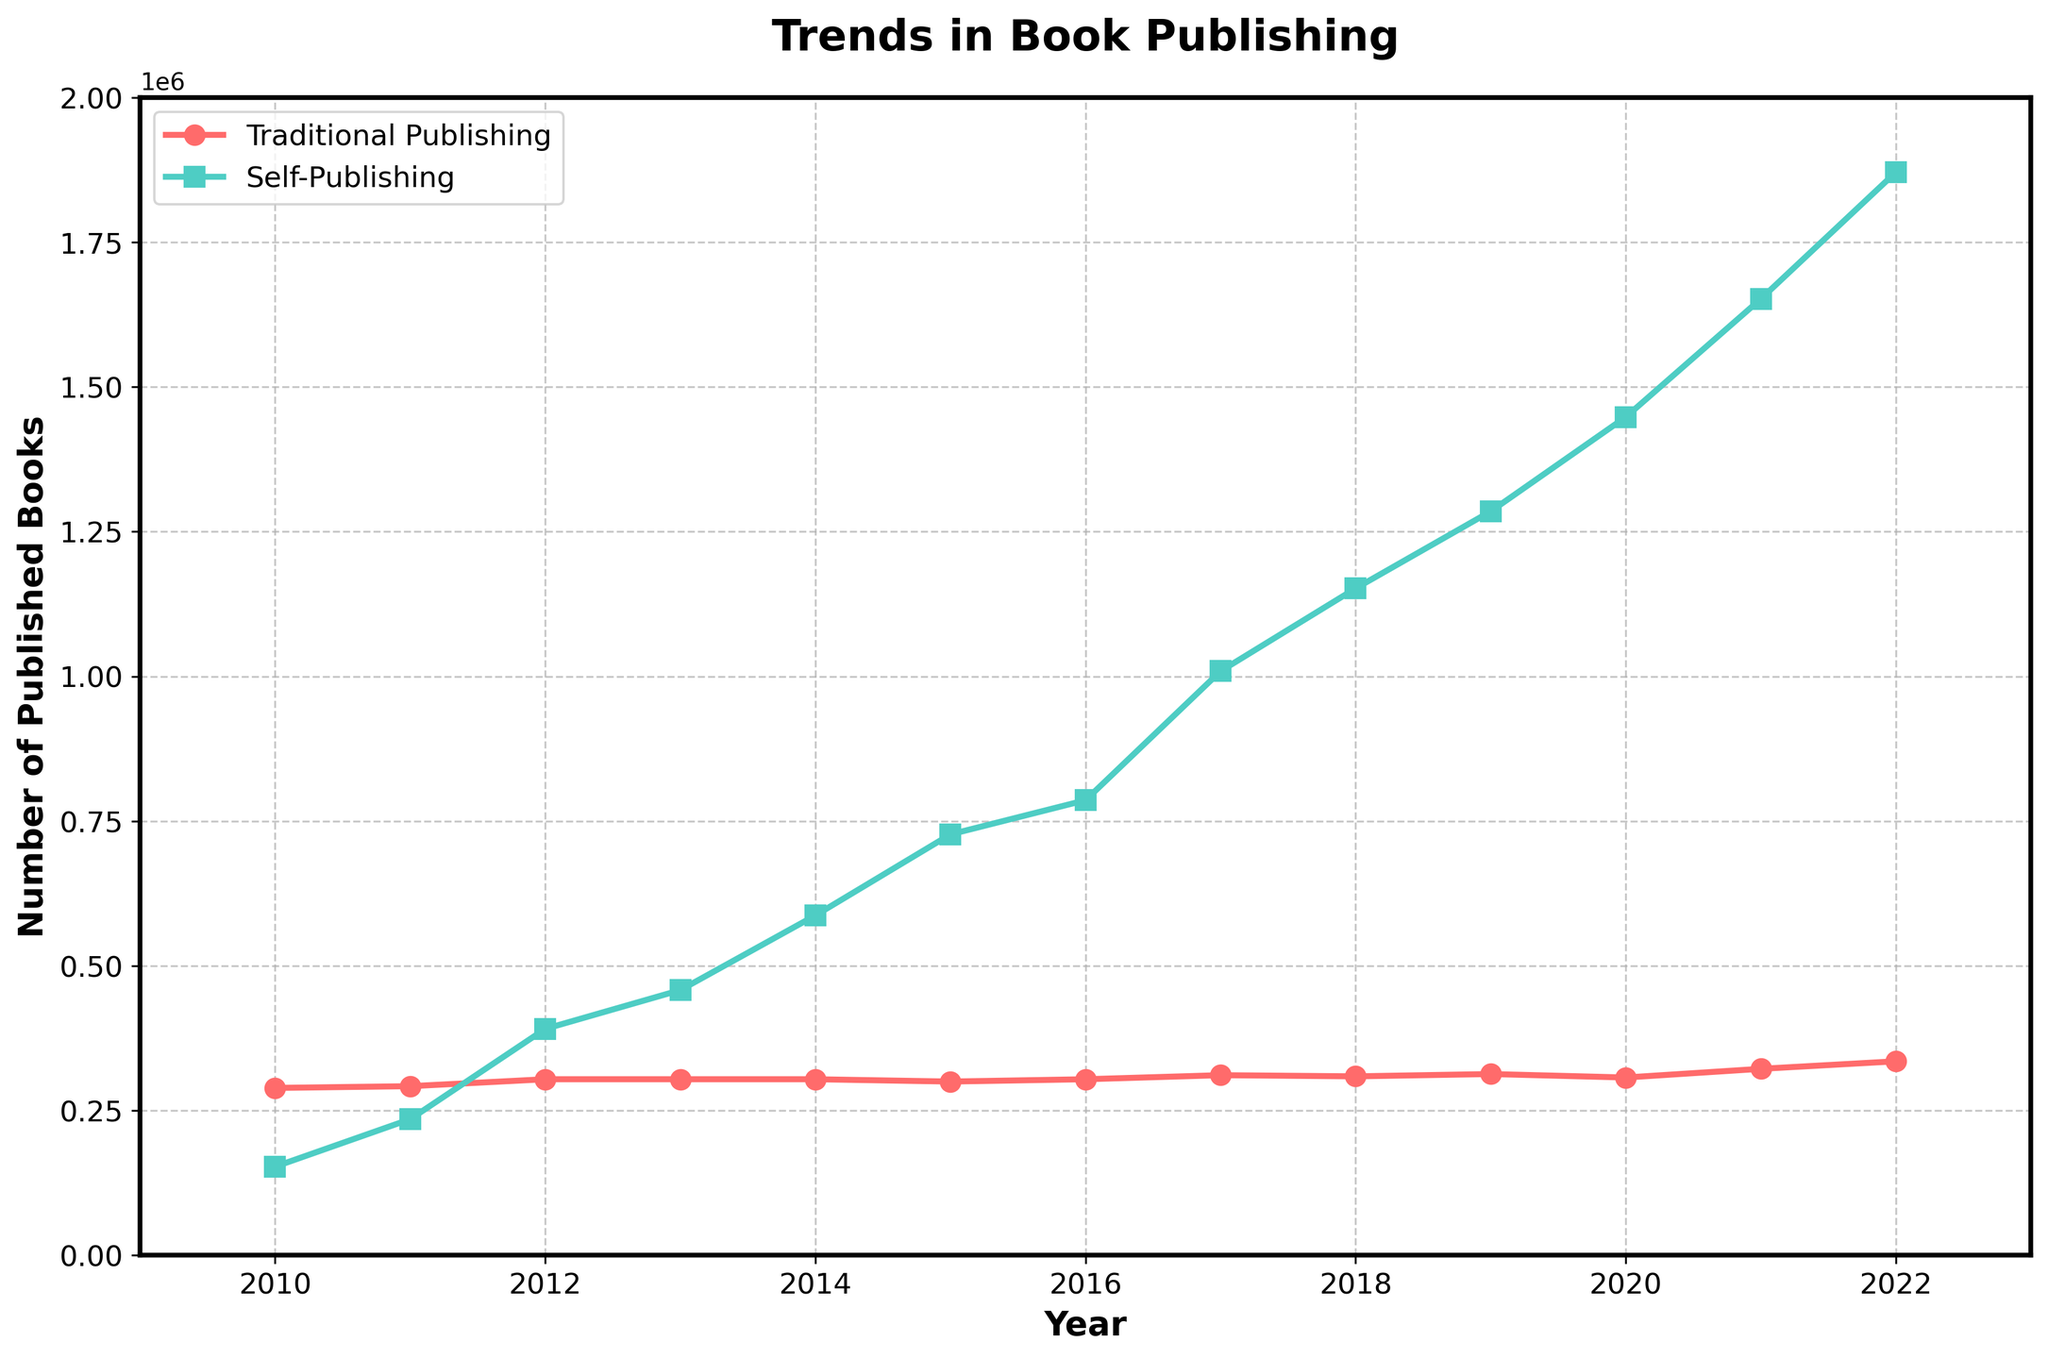Which year saw the highest number of books published through self-publishing? Looking at the graph, the highest point on the self-publishing line corresponds to the year 2022.
Answer: 2022 How much more books were published through self-publishing than traditional publishing in 2022? From the figure, self-publishing in 2022 was 1,871,000 books, and traditional publishing was 335,000 books. The difference is 1,871,000 - 335,000 = 1,536,000.
Answer: 1,536,000 In which years did the number of traditionally published books remain constant? The traditional publishing curve has a flat section from 2012 to 2014 where it remains at 304,000 books.
Answer: 2012 to 2014 By how much did the number of traditional publishing books increase from its lowest point in the data to its highest? The lowest number of traditionally published books is 289,000 in 2010, and the highest is 335,000 in 2022. The increase is 335,000 - 289,000 = 46,000.
Answer: 46,000 What is the average number of self-published books between 2010 and 2022? The sum of self-published books from 2010 to 2022 is (153,000 + 235,000 + 391,000 + 458,000 + 587,000 + 727,000 + 786,000 + 1,009,000 + 1,152,000 + 1,285,000 + 1,448,000 + 1,652,000 + 1,871,000) = 11,554,000. The number of years is 13. The average is 11,554,000 / 13 = 888,000.
Answer: 888,000 When did self-publishing first surpass 1 million published books? Observing the self-publishing line, the first year it crosses the 1 million mark is 2017.
Answer: 2017 Which year has the smallest gap between traditionally published books and self-published books? How much is the gap? The smallest gap can be seen in 2010, with traditional publishing at 289,000 and self-publishing at 153,000. The gap is 289,000 - 153,000 = 136,000.
Answer: 2010, 136,000 What is the general trend in the number of books published through traditional publishing over the years? Observing the trend of the traditional publishing line, there are minor fluctuations but a general slight upward trend from 289,000 in 2010 to 335,000 in 2022.
Answer: Slight upward trend 